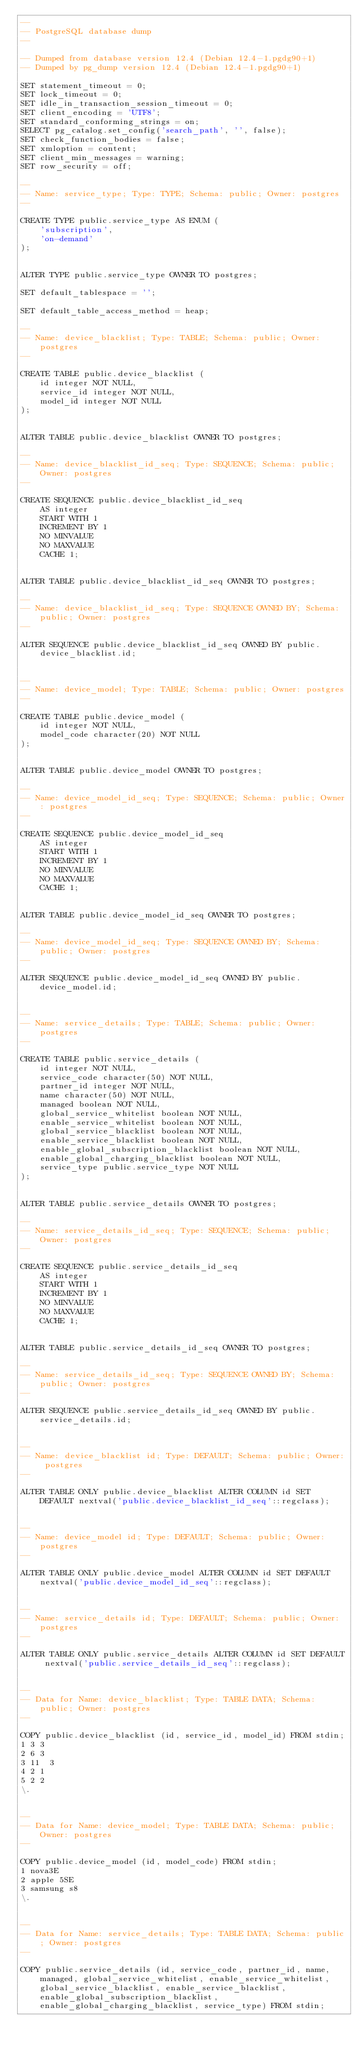Convert code to text. <code><loc_0><loc_0><loc_500><loc_500><_SQL_>--
-- PostgreSQL database dump
--

-- Dumped from database version 12.4 (Debian 12.4-1.pgdg90+1)
-- Dumped by pg_dump version 12.4 (Debian 12.4-1.pgdg90+1)

SET statement_timeout = 0;
SET lock_timeout = 0;
SET idle_in_transaction_session_timeout = 0;
SET client_encoding = 'UTF8';
SET standard_conforming_strings = on;
SELECT pg_catalog.set_config('search_path', '', false);
SET check_function_bodies = false;
SET xmloption = content;
SET client_min_messages = warning;
SET row_security = off;

--
-- Name: service_type; Type: TYPE; Schema: public; Owner: postgres
--

CREATE TYPE public.service_type AS ENUM (
    'subscription',
    'on-demand'
);


ALTER TYPE public.service_type OWNER TO postgres;

SET default_tablespace = '';

SET default_table_access_method = heap;

--
-- Name: device_blacklist; Type: TABLE; Schema: public; Owner: postgres
--

CREATE TABLE public.device_blacklist (
    id integer NOT NULL,
    service_id integer NOT NULL,
    model_id integer NOT NULL
);


ALTER TABLE public.device_blacklist OWNER TO postgres;

--
-- Name: device_blacklist_id_seq; Type: SEQUENCE; Schema: public; Owner: postgres
--

CREATE SEQUENCE public.device_blacklist_id_seq
    AS integer
    START WITH 1
    INCREMENT BY 1
    NO MINVALUE
    NO MAXVALUE
    CACHE 1;


ALTER TABLE public.device_blacklist_id_seq OWNER TO postgres;

--
-- Name: device_blacklist_id_seq; Type: SEQUENCE OWNED BY; Schema: public; Owner: postgres
--

ALTER SEQUENCE public.device_blacklist_id_seq OWNED BY public.device_blacklist.id;


--
-- Name: device_model; Type: TABLE; Schema: public; Owner: postgres
--

CREATE TABLE public.device_model (
    id integer NOT NULL,
    model_code character(20) NOT NULL
);


ALTER TABLE public.device_model OWNER TO postgres;

--
-- Name: device_model_id_seq; Type: SEQUENCE; Schema: public; Owner: postgres
--

CREATE SEQUENCE public.device_model_id_seq
    AS integer
    START WITH 1
    INCREMENT BY 1
    NO MINVALUE
    NO MAXVALUE
    CACHE 1;


ALTER TABLE public.device_model_id_seq OWNER TO postgres;

--
-- Name: device_model_id_seq; Type: SEQUENCE OWNED BY; Schema: public; Owner: postgres
--

ALTER SEQUENCE public.device_model_id_seq OWNED BY public.device_model.id;


--
-- Name: service_details; Type: TABLE; Schema: public; Owner: postgres
--

CREATE TABLE public.service_details (
    id integer NOT NULL,
    service_code character(50) NOT NULL,
    partner_id integer NOT NULL,
    name character(50) NOT NULL,
    managed boolean NOT NULL,
    global_service_whitelist boolean NOT NULL,
    enable_service_whitelist boolean NOT NULL,
    global_service_blacklist boolean NOT NULL,
    enable_service_blacklist boolean NOT NULL,
    enable_global_subscription_blacklist boolean NOT NULL,
    enable_global_charging_blacklist boolean NOT NULL,
    service_type public.service_type NOT NULL
);


ALTER TABLE public.service_details OWNER TO postgres;

--
-- Name: service_details_id_seq; Type: SEQUENCE; Schema: public; Owner: postgres
--

CREATE SEQUENCE public.service_details_id_seq
    AS integer
    START WITH 1
    INCREMENT BY 1
    NO MINVALUE
    NO MAXVALUE
    CACHE 1;


ALTER TABLE public.service_details_id_seq OWNER TO postgres;

--
-- Name: service_details_id_seq; Type: SEQUENCE OWNED BY; Schema: public; Owner: postgres
--

ALTER SEQUENCE public.service_details_id_seq OWNED BY public.service_details.id;


--
-- Name: device_blacklist id; Type: DEFAULT; Schema: public; Owner: postgres
--

ALTER TABLE ONLY public.device_blacklist ALTER COLUMN id SET DEFAULT nextval('public.device_blacklist_id_seq'::regclass);


--
-- Name: device_model id; Type: DEFAULT; Schema: public; Owner: postgres
--

ALTER TABLE ONLY public.device_model ALTER COLUMN id SET DEFAULT nextval('public.device_model_id_seq'::regclass);


--
-- Name: service_details id; Type: DEFAULT; Schema: public; Owner: postgres
--

ALTER TABLE ONLY public.service_details ALTER COLUMN id SET DEFAULT nextval('public.service_details_id_seq'::regclass);


--
-- Data for Name: device_blacklist; Type: TABLE DATA; Schema: public; Owner: postgres
--

COPY public.device_blacklist (id, service_id, model_id) FROM stdin;
1	3	3
2	6	3
3	11	3
4	2	1
5	2	2
\.


--
-- Data for Name: device_model; Type: TABLE DATA; Schema: public; Owner: postgres
--

COPY public.device_model (id, model_code) FROM stdin;
1	nova3E              
2	apple 5SE           
3	samsung s8          
\.


--
-- Data for Name: service_details; Type: TABLE DATA; Schema: public; Owner: postgres
--

COPY public.service_details (id, service_code, partner_id, name, managed, global_service_whitelist, enable_service_whitelist, global_service_blacklist, enable_service_blacklist, enable_global_subscription_blacklist, enable_global_charging_blacklist, service_type) FROM stdin;</code> 